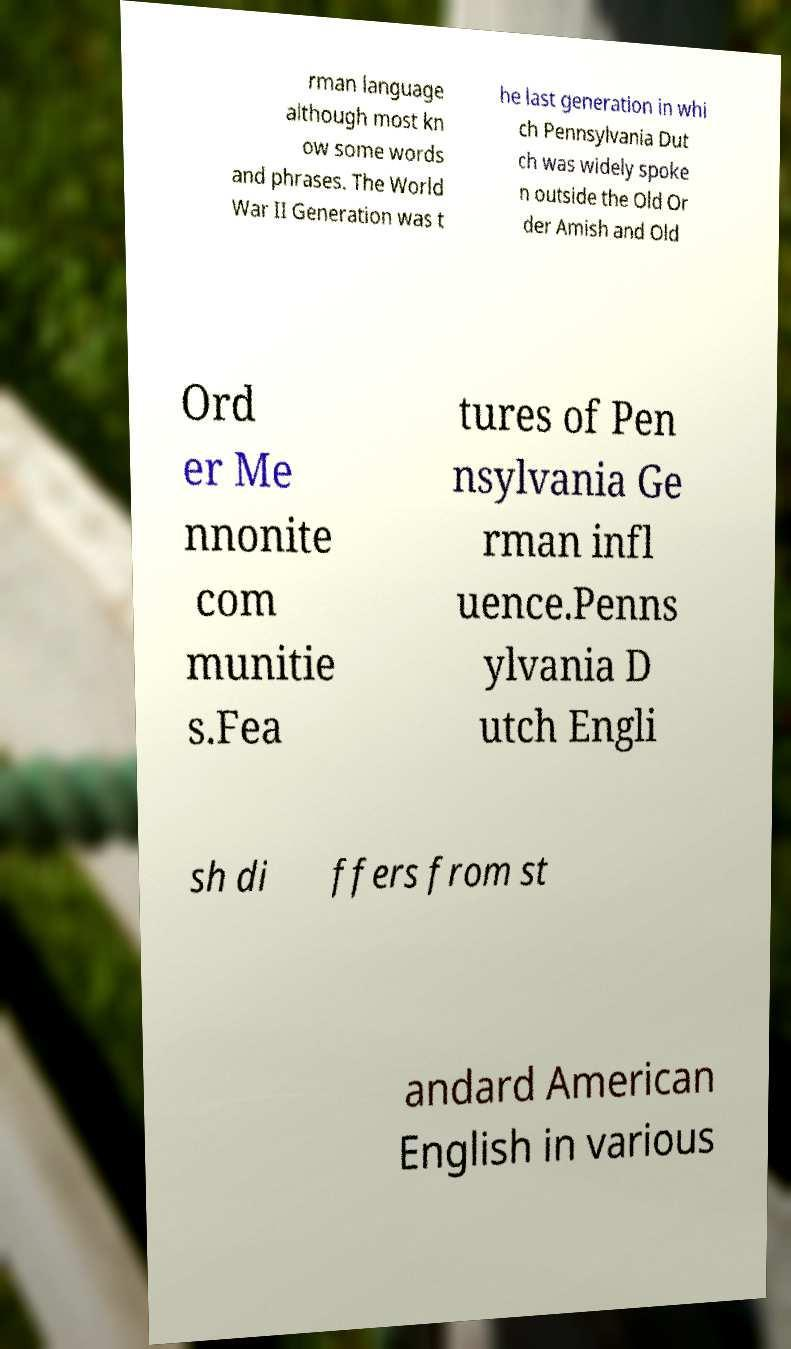I need the written content from this picture converted into text. Can you do that? rman language although most kn ow some words and phrases. The World War II Generation was t he last generation in whi ch Pennsylvania Dut ch was widely spoke n outside the Old Or der Amish and Old Ord er Me nnonite com munitie s.Fea tures of Pen nsylvania Ge rman infl uence.Penns ylvania D utch Engli sh di ffers from st andard American English in various 